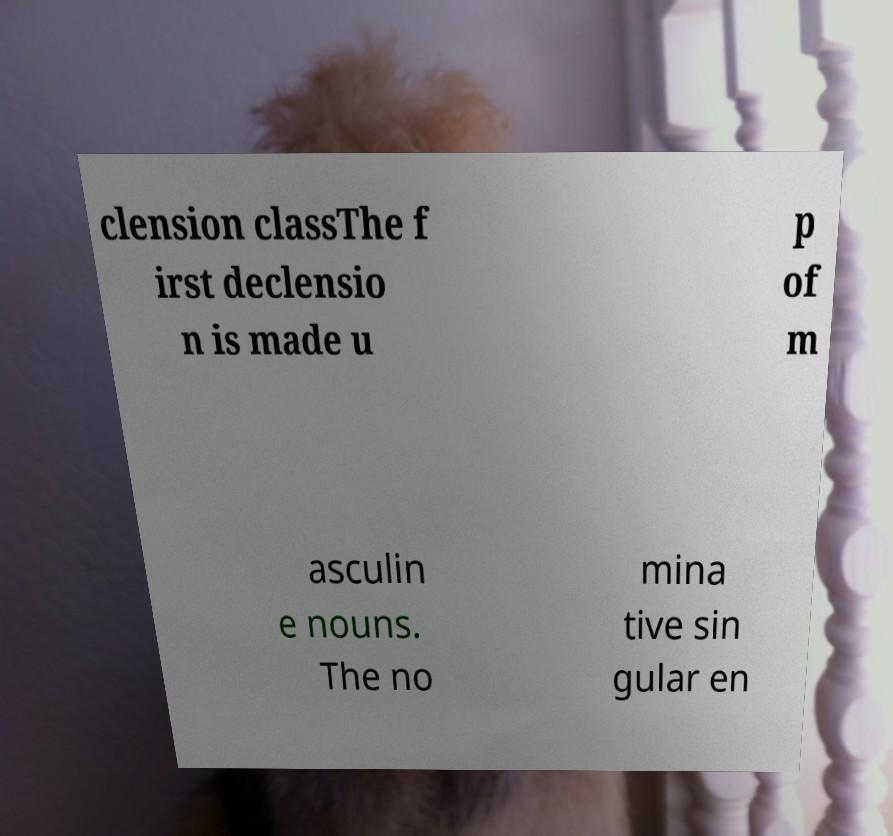Can you accurately transcribe the text from the provided image for me? clension classThe f irst declensio n is made u p of m asculin e nouns. The no mina tive sin gular en 